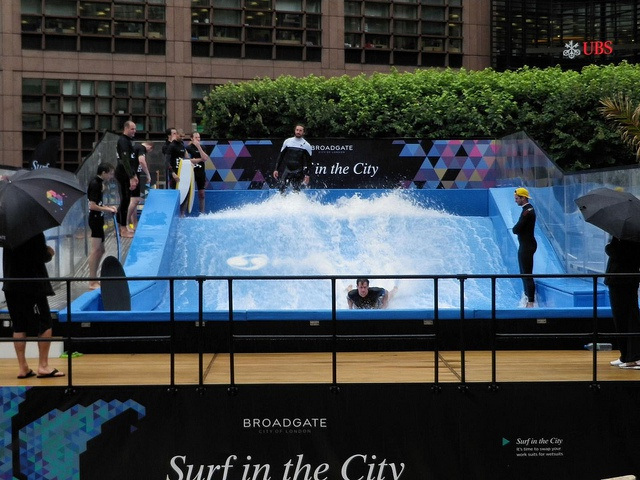Describe the objects in this image and their specific colors. I can see people in gray, black, brown, and maroon tones, umbrella in gray and black tones, people in gray, black, navy, and darkgray tones, umbrella in gray and black tones, and people in gray and black tones in this image. 